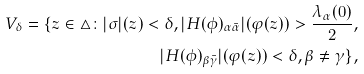<formula> <loc_0><loc_0><loc_500><loc_500>V _ { \delta } = \{ z \in \triangle \colon | \sigma | ( z ) < \delta , | H ( \phi ) _ { \alpha \bar { \alpha } } | ( \varphi ( z ) ) > \frac { \lambda _ { \alpha } ( 0 ) } { 2 } , \\ | H ( \phi ) _ { \beta \bar { \gamma } } | ( \varphi ( z ) ) < \delta , \beta \neq \gamma \} ,</formula> 